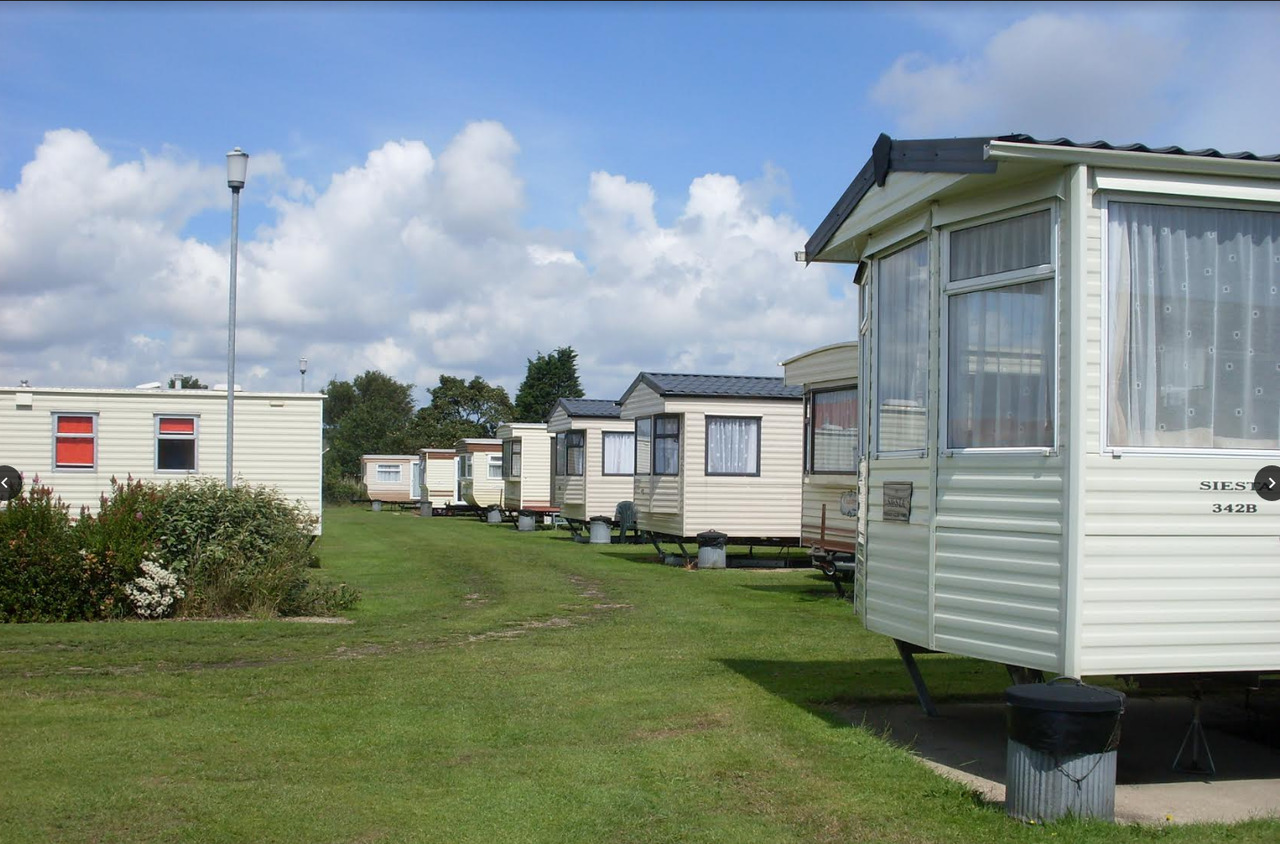If you were to animate the scene in a vibrant, bustling park, how would you depict it? In a vibrant, bustling animation of the park, the scene would be colorful and lively. Bright sun glints off the caravan rooftops as children run and play games on the grass, their laughter blending with the chirping of birds. Families gather around picnic tables, sharing meals with animated conversation. Paths bustle with people walking dogs, bicycling, and carrying groceries. There are vibrant flowers around the caravans, and kites flying high in the clear blue sky. The scene shifts to the evening where string lights illuminate the common areas, and residents gather for community events, sharing stories and creating a warm, inviting atmosphere. 